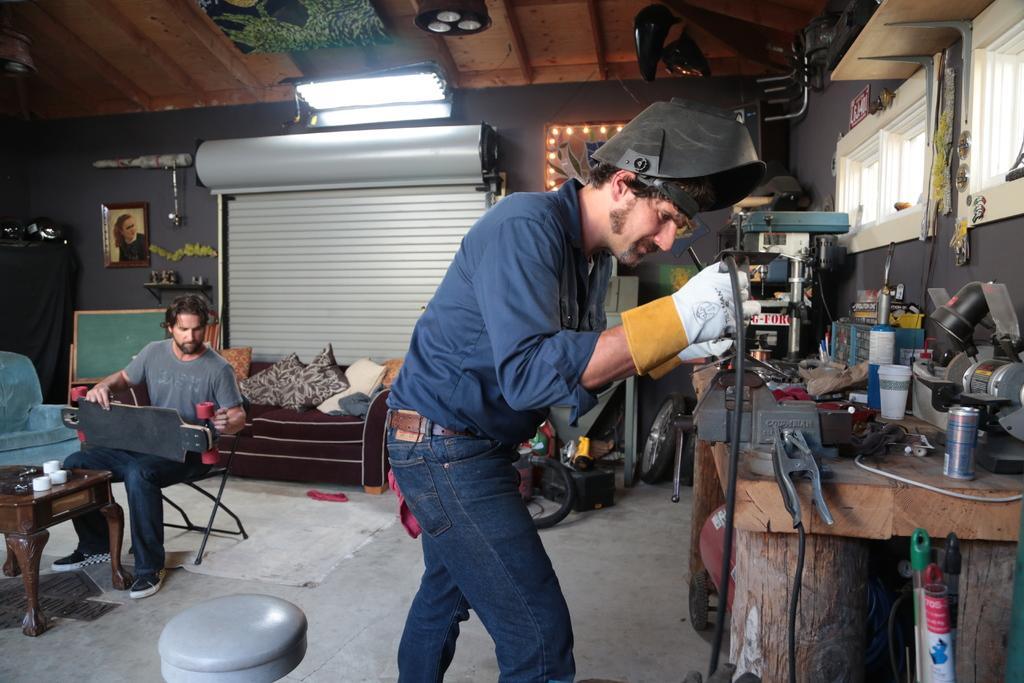Could you give a brief overview of what you see in this image? In this picture I can see a man is standing. This man is wearing a shirt, blue jeans and other objects. On the left side I can see a man is sitting on a chair and holding some object. I can also see a table which has some objects on it. In the background I can see lights on the ceiling, a sofa which has some cushions on it. I can also see a photo and some other objects attached to the wall. On the right side I can see a table which has some machines and other objects. 